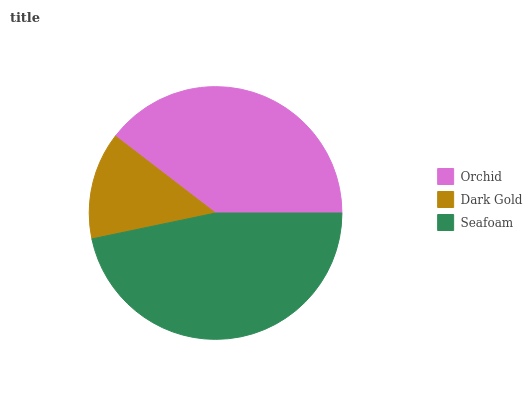Is Dark Gold the minimum?
Answer yes or no. Yes. Is Seafoam the maximum?
Answer yes or no. Yes. Is Seafoam the minimum?
Answer yes or no. No. Is Dark Gold the maximum?
Answer yes or no. No. Is Seafoam greater than Dark Gold?
Answer yes or no. Yes. Is Dark Gold less than Seafoam?
Answer yes or no. Yes. Is Dark Gold greater than Seafoam?
Answer yes or no. No. Is Seafoam less than Dark Gold?
Answer yes or no. No. Is Orchid the high median?
Answer yes or no. Yes. Is Orchid the low median?
Answer yes or no. Yes. Is Dark Gold the high median?
Answer yes or no. No. Is Dark Gold the low median?
Answer yes or no. No. 